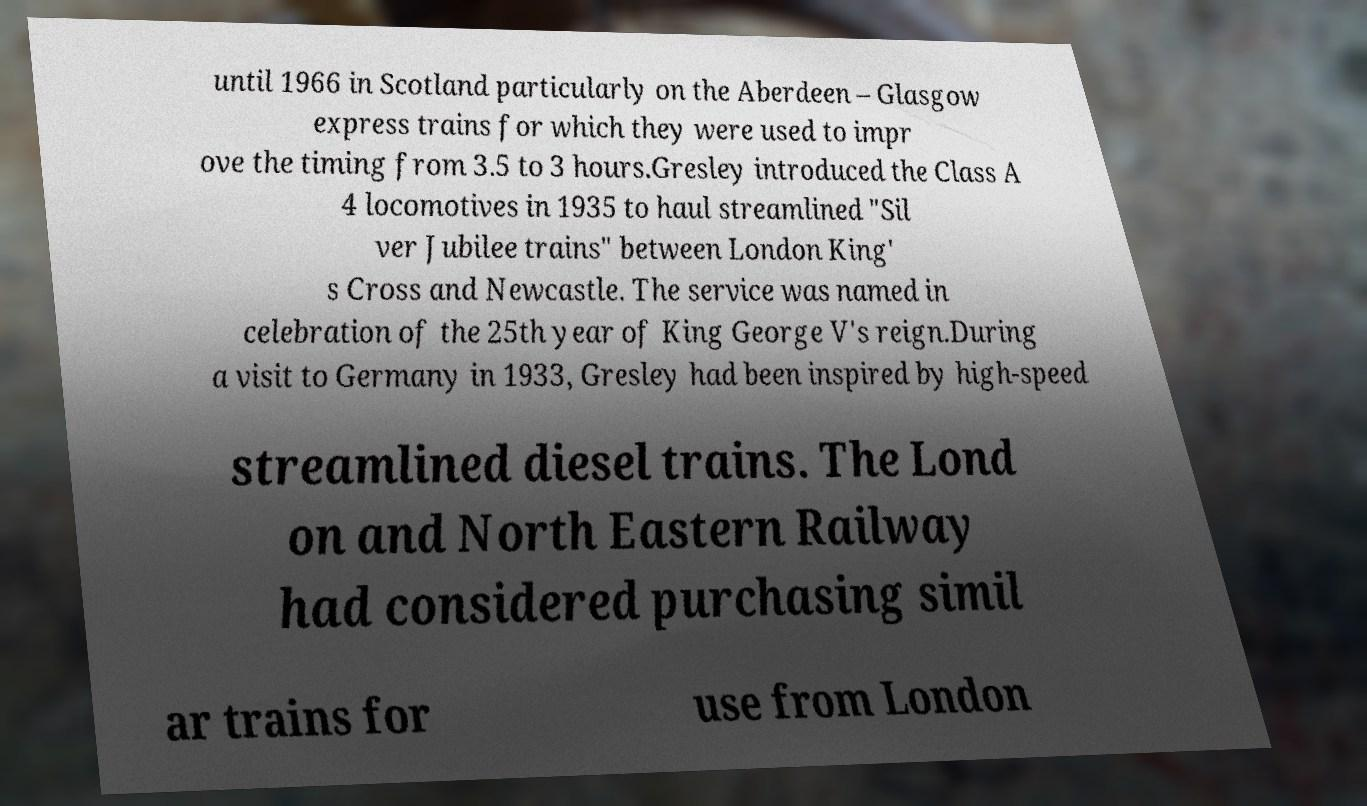I need the written content from this picture converted into text. Can you do that? until 1966 in Scotland particularly on the Aberdeen – Glasgow express trains for which they were used to impr ove the timing from 3.5 to 3 hours.Gresley introduced the Class A 4 locomotives in 1935 to haul streamlined "Sil ver Jubilee trains" between London King' s Cross and Newcastle. The service was named in celebration of the 25th year of King George V's reign.During a visit to Germany in 1933, Gresley had been inspired by high-speed streamlined diesel trains. The Lond on and North Eastern Railway had considered purchasing simil ar trains for use from London 